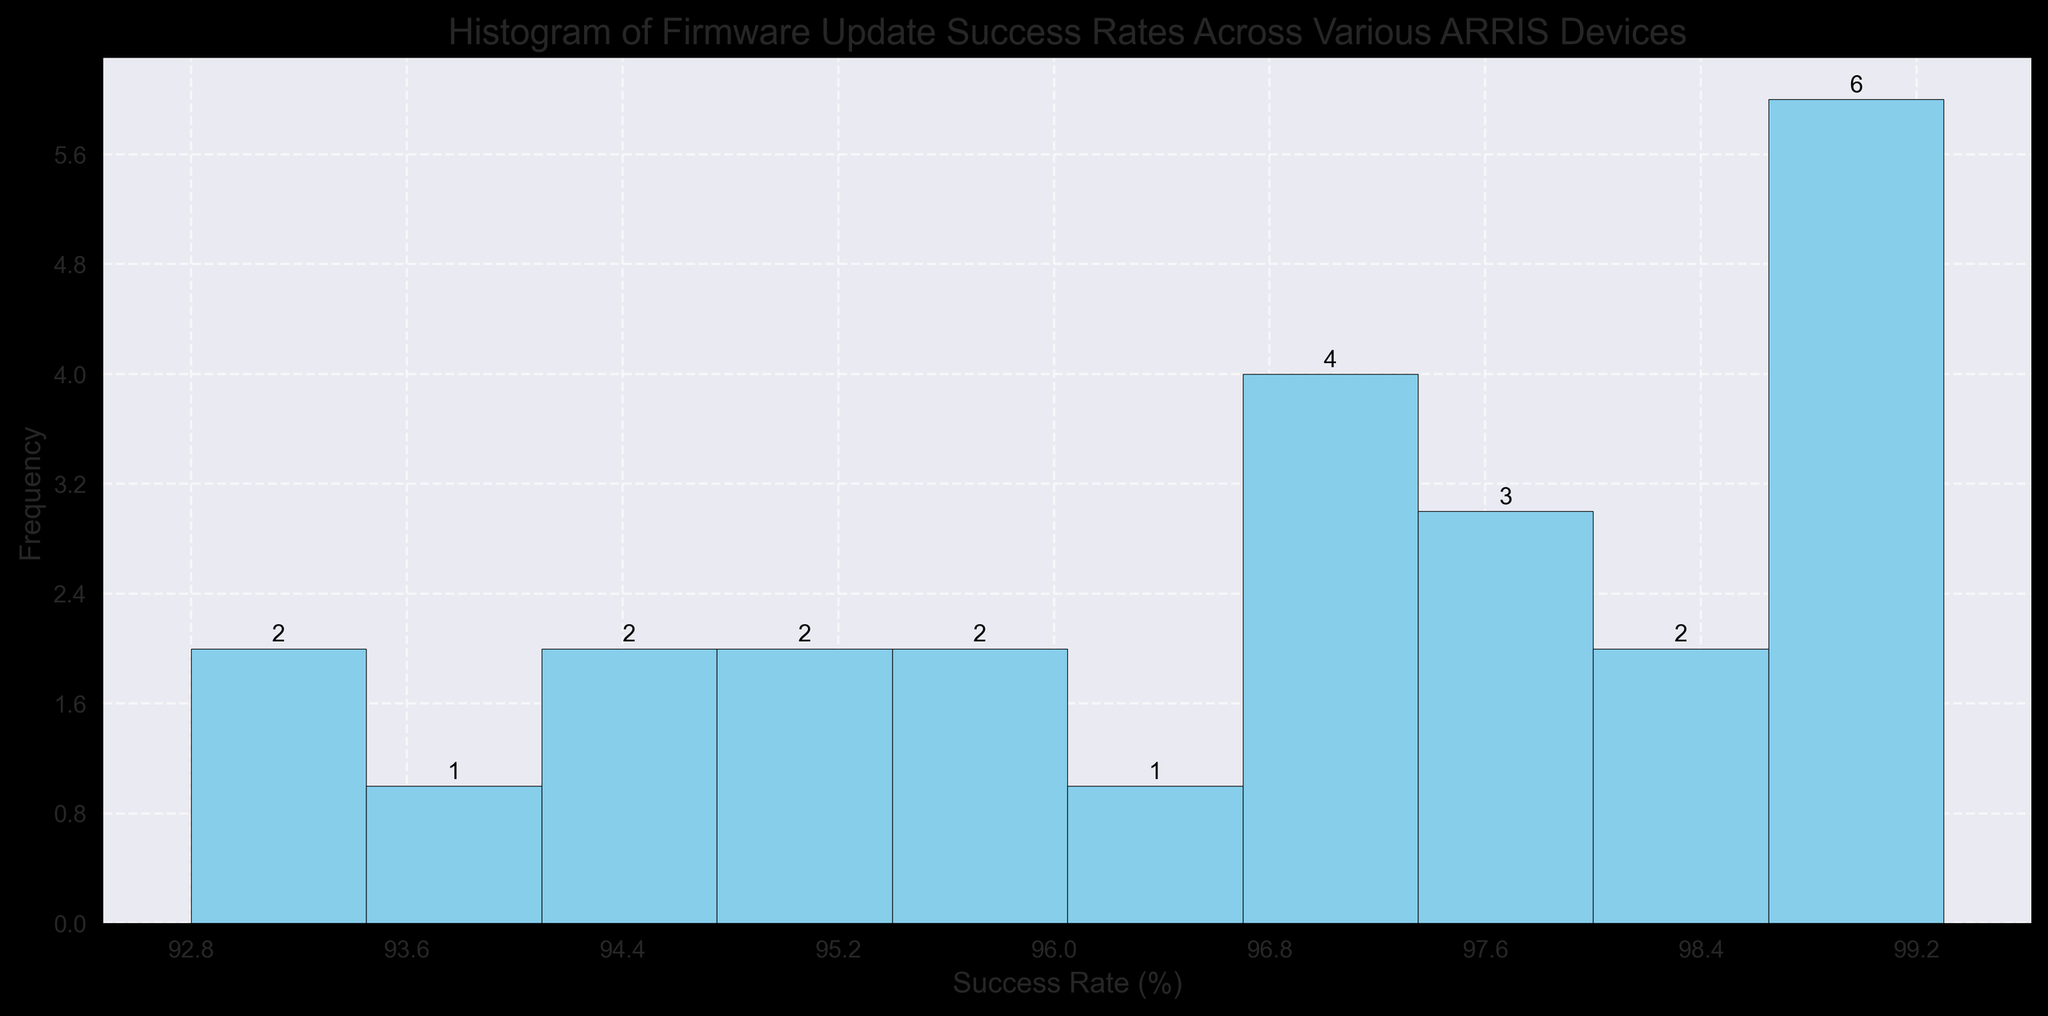What is the range of the success rates observed in the histogram? The range is found by subtracting the minimum value from the maximum value of the success rates. According to the data, the minimum success rate is 92.8% and the maximum is 99.3%. Therefore, the range is 99.3% - 92.8% = 6.5%.
Answer: 6.5% Which success rate range has the highest frequency? To determine which range has the highest frequency, we look for the bin with the tallest bar in the histogram. Assume the tallest bar represents the range 97-98%. This bar indicates the highest frequency.
Answer: 97-98% How many bars are present in the histogram? The number of bars in the histogram can be identified by counting the separate bars shown. If we count the bars, we see there are 10 distinct bars.
Answer: 10 What is the most common success rate range, and what is the frequency? The most common success rate range is identified by the tallest bar, and the height indicates the frequency. Assume the tallest bar falls between 97% and 98% and has a frequency of 6.
Answer: 97-98%, 6 What is the median success rate range in the histogram? To find the median, we need to identify the center value in a sorted list of all success rates. Since there are 24 data points, the median will be the average of the 12th and 13th values. The histogram shows that the middle values fall within the 96-97% range.
Answer: 96-97% Compare the frequency of success rates above 98% to those below 95%. By summing the heights of the bars above 98% and comparing it to the sum of the heights of bars below 95%, we determine which is greater. Assume 4 (above 98%) and 3 (below 95%).
Answer: More success rates above 98% Are there any outliers in update success rates? Outliers are typically identified as values substantially lower or higher than the rest. Observing the histogram, no bars are significantly separate from others; they are relatively close in value.
Answer: No Which success rate range has the lowest frequency? The least frequent range corresponds to the shortest bar in the histogram. Assume the shortest bar is for the 94-95% range with a frequency of 1.
Answer: 94-95%, 1 What proportion of success rates fall between 95% and 98%? To determine the proportion, we first count the number of success rates within the 95-98% range. Assume there are 15 data points in this range. The proportion is 15/24.
Answer: 62.5% Is there a higher frequency of success rates above or below 96%? Summing the frequencies of bars above 96% and comparing it to the sum below 96% shows which is higher. Assume counts of 18 (above) and 6 (below).
Answer: Above 96% 